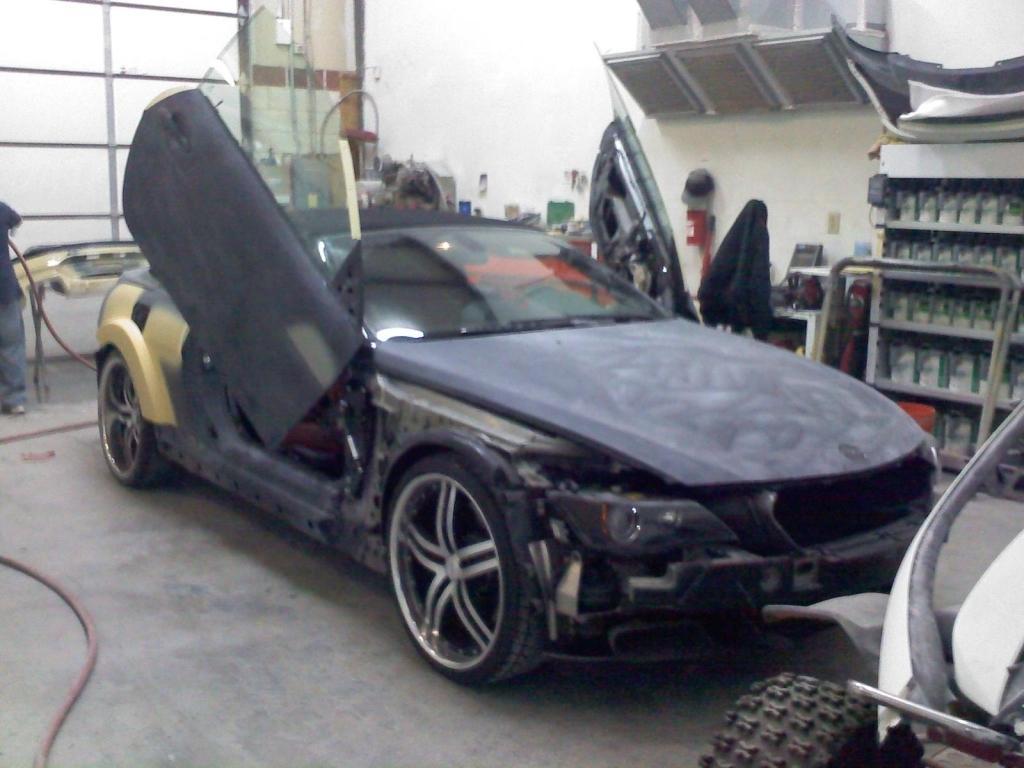In one or two sentences, can you explain what this image depicts? In this image it looks like a car repairing shed. In the middle there is a black car. On the left side there is a man working by holding the pipe. In the background there are spare parts. On the right side there is a cupboard in which there are bottles. On the right side bottom there is another vehicle. 